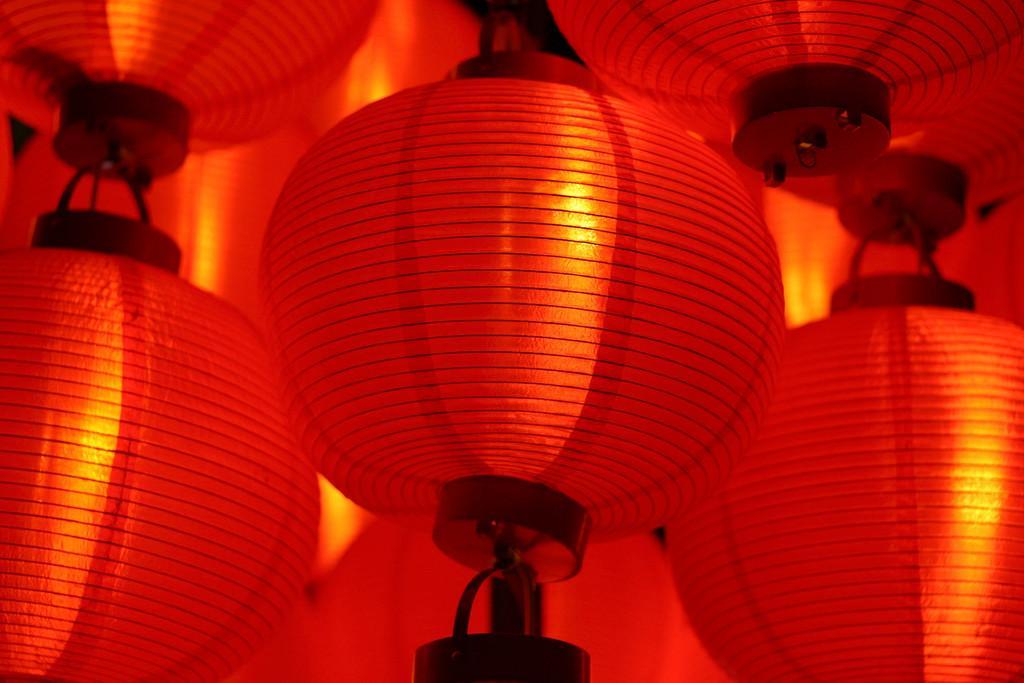In one or two sentences, can you explain what this image depicts? The picture consists of paper lanterns. The lanterns are in red color. 